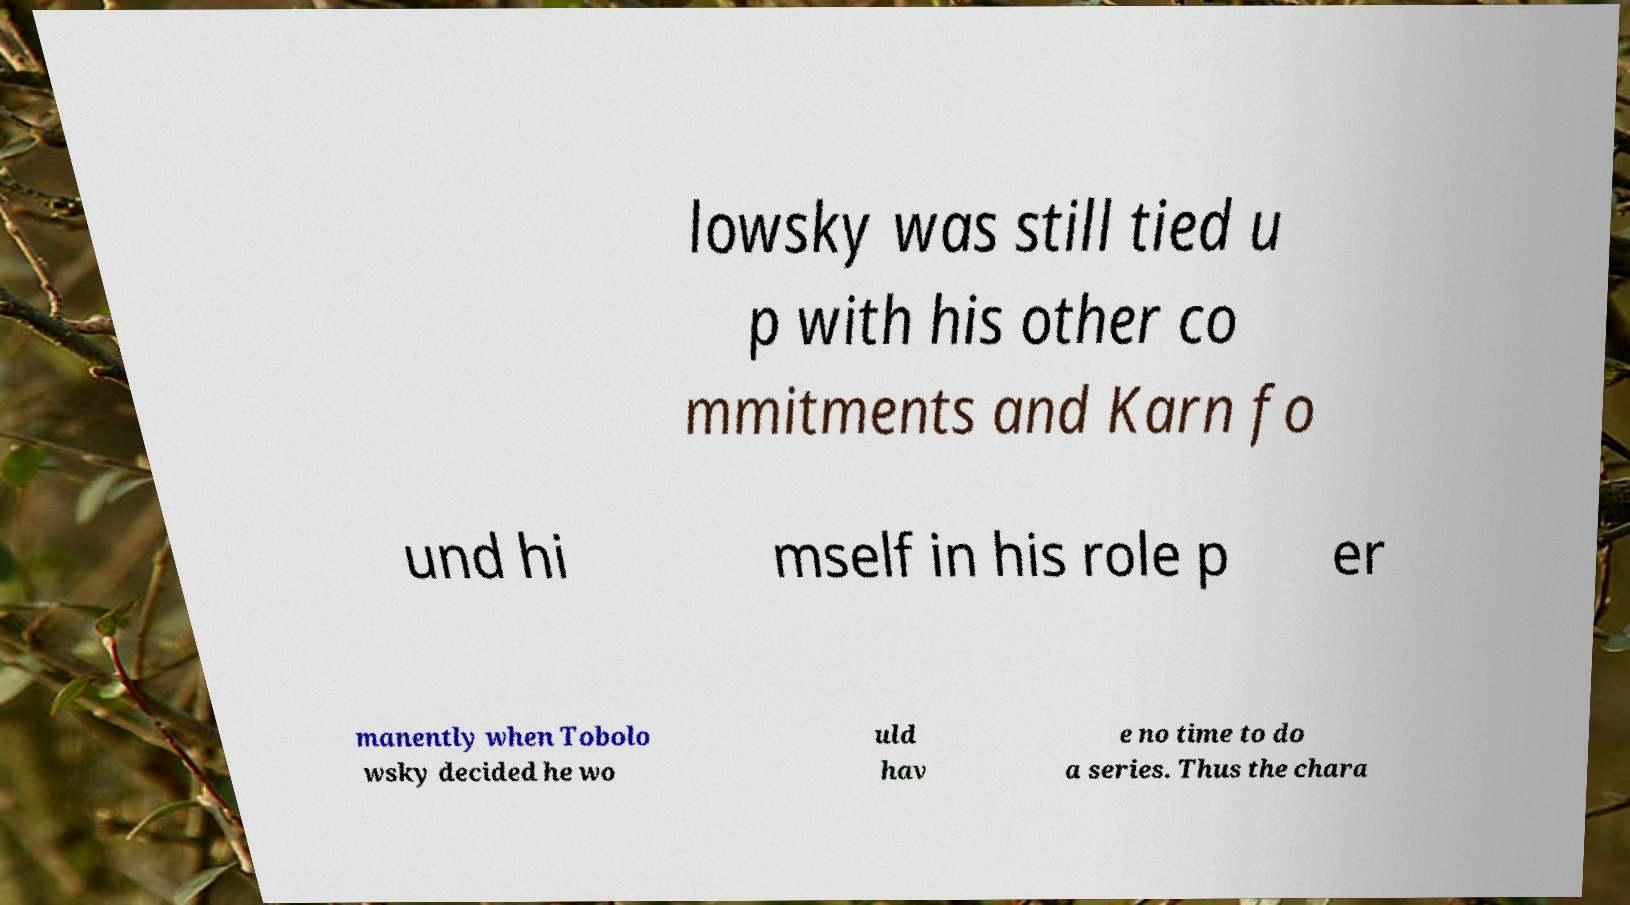Please identify and transcribe the text found in this image. lowsky was still tied u p with his other co mmitments and Karn fo und hi mself in his role p er manently when Tobolo wsky decided he wo uld hav e no time to do a series. Thus the chara 